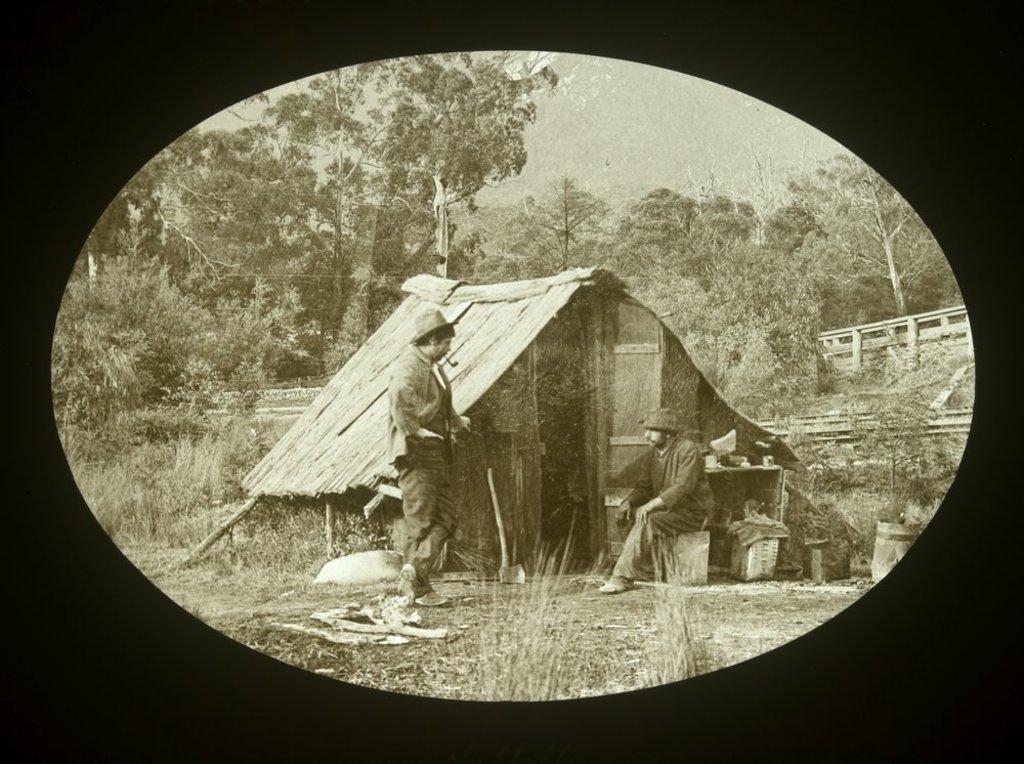Describe this image in one or two sentences. This image consists of a poster. This image is a black and white image. At the bottom of the image there is ground with grass on it. In the background there are many trees and plants. On the right side of the image there is a wooden fence. In the middle of the image there is a hut and there are a few things. A man is sitting and a man is standing on the ground. 